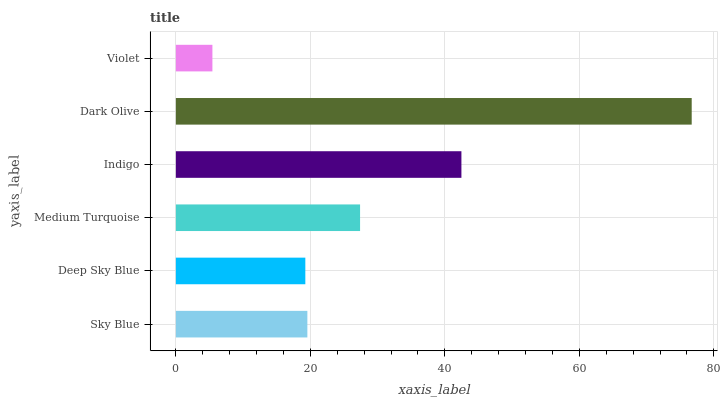Is Violet the minimum?
Answer yes or no. Yes. Is Dark Olive the maximum?
Answer yes or no. Yes. Is Deep Sky Blue the minimum?
Answer yes or no. No. Is Deep Sky Blue the maximum?
Answer yes or no. No. Is Sky Blue greater than Deep Sky Blue?
Answer yes or no. Yes. Is Deep Sky Blue less than Sky Blue?
Answer yes or no. Yes. Is Deep Sky Blue greater than Sky Blue?
Answer yes or no. No. Is Sky Blue less than Deep Sky Blue?
Answer yes or no. No. Is Medium Turquoise the high median?
Answer yes or no. Yes. Is Sky Blue the low median?
Answer yes or no. Yes. Is Deep Sky Blue the high median?
Answer yes or no. No. Is Indigo the low median?
Answer yes or no. No. 